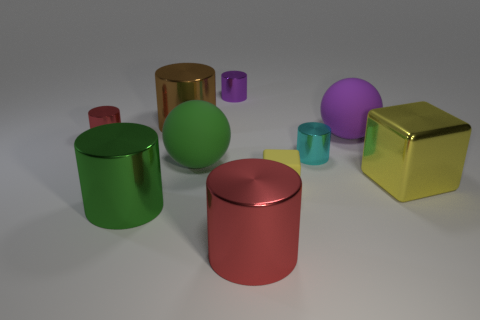Subtract all brown balls. How many red cylinders are left? 2 Subtract all big green cylinders. How many cylinders are left? 5 Subtract all green cylinders. How many cylinders are left? 5 Subtract all cubes. How many objects are left? 8 Subtract all purple cylinders. Subtract all green cubes. How many cylinders are left? 5 Subtract all blue metallic cylinders. Subtract all small red metal objects. How many objects are left? 9 Add 3 small yellow blocks. How many small yellow blocks are left? 4 Add 2 small objects. How many small objects exist? 6 Subtract 0 brown spheres. How many objects are left? 10 